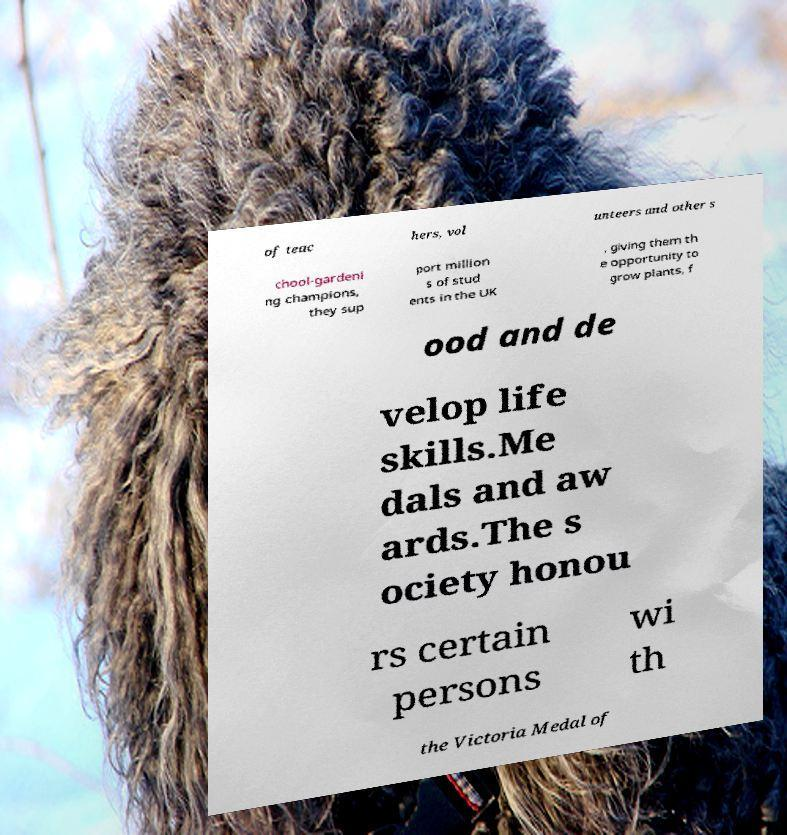Could you assist in decoding the text presented in this image and type it out clearly? of teac hers, vol unteers and other s chool-gardeni ng champions, they sup port million s of stud ents in the UK , giving them th e opportunity to grow plants, f ood and de velop life skills.Me dals and aw ards.The s ociety honou rs certain persons wi th the Victoria Medal of 